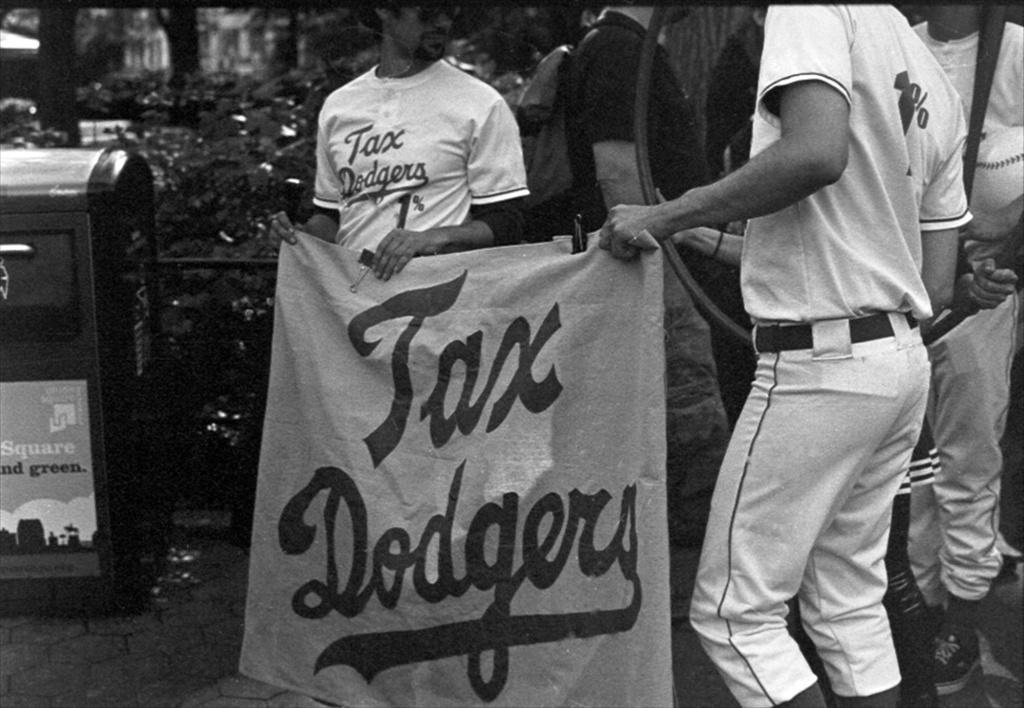Please provide a concise description of this image. In this black and white image there are a few people standing and holding a banner with some text on it and few are holding some objects in their hands and there is an object in front of them. In the background there are trees and buildings 